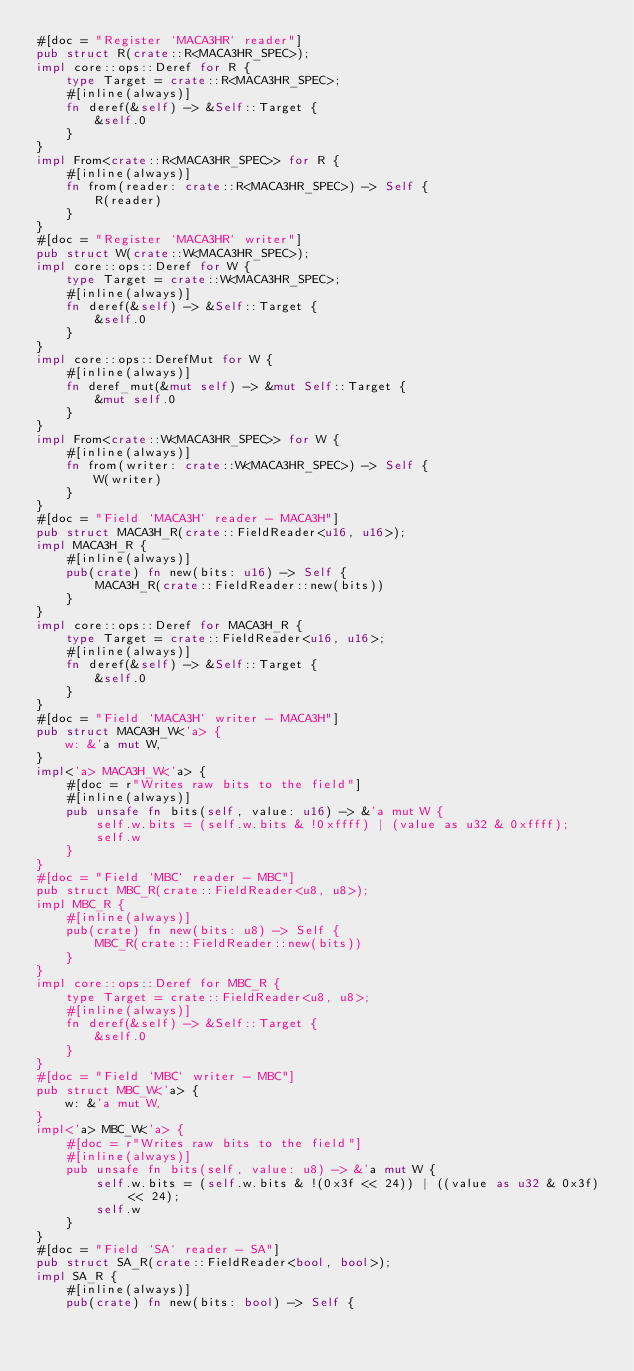Convert code to text. <code><loc_0><loc_0><loc_500><loc_500><_Rust_>#[doc = "Register `MACA3HR` reader"]
pub struct R(crate::R<MACA3HR_SPEC>);
impl core::ops::Deref for R {
    type Target = crate::R<MACA3HR_SPEC>;
    #[inline(always)]
    fn deref(&self) -> &Self::Target {
        &self.0
    }
}
impl From<crate::R<MACA3HR_SPEC>> for R {
    #[inline(always)]
    fn from(reader: crate::R<MACA3HR_SPEC>) -> Self {
        R(reader)
    }
}
#[doc = "Register `MACA3HR` writer"]
pub struct W(crate::W<MACA3HR_SPEC>);
impl core::ops::Deref for W {
    type Target = crate::W<MACA3HR_SPEC>;
    #[inline(always)]
    fn deref(&self) -> &Self::Target {
        &self.0
    }
}
impl core::ops::DerefMut for W {
    #[inline(always)]
    fn deref_mut(&mut self) -> &mut Self::Target {
        &mut self.0
    }
}
impl From<crate::W<MACA3HR_SPEC>> for W {
    #[inline(always)]
    fn from(writer: crate::W<MACA3HR_SPEC>) -> Self {
        W(writer)
    }
}
#[doc = "Field `MACA3H` reader - MACA3H"]
pub struct MACA3H_R(crate::FieldReader<u16, u16>);
impl MACA3H_R {
    #[inline(always)]
    pub(crate) fn new(bits: u16) -> Self {
        MACA3H_R(crate::FieldReader::new(bits))
    }
}
impl core::ops::Deref for MACA3H_R {
    type Target = crate::FieldReader<u16, u16>;
    #[inline(always)]
    fn deref(&self) -> &Self::Target {
        &self.0
    }
}
#[doc = "Field `MACA3H` writer - MACA3H"]
pub struct MACA3H_W<'a> {
    w: &'a mut W,
}
impl<'a> MACA3H_W<'a> {
    #[doc = r"Writes raw bits to the field"]
    #[inline(always)]
    pub unsafe fn bits(self, value: u16) -> &'a mut W {
        self.w.bits = (self.w.bits & !0xffff) | (value as u32 & 0xffff);
        self.w
    }
}
#[doc = "Field `MBC` reader - MBC"]
pub struct MBC_R(crate::FieldReader<u8, u8>);
impl MBC_R {
    #[inline(always)]
    pub(crate) fn new(bits: u8) -> Self {
        MBC_R(crate::FieldReader::new(bits))
    }
}
impl core::ops::Deref for MBC_R {
    type Target = crate::FieldReader<u8, u8>;
    #[inline(always)]
    fn deref(&self) -> &Self::Target {
        &self.0
    }
}
#[doc = "Field `MBC` writer - MBC"]
pub struct MBC_W<'a> {
    w: &'a mut W,
}
impl<'a> MBC_W<'a> {
    #[doc = r"Writes raw bits to the field"]
    #[inline(always)]
    pub unsafe fn bits(self, value: u8) -> &'a mut W {
        self.w.bits = (self.w.bits & !(0x3f << 24)) | ((value as u32 & 0x3f) << 24);
        self.w
    }
}
#[doc = "Field `SA` reader - SA"]
pub struct SA_R(crate::FieldReader<bool, bool>);
impl SA_R {
    #[inline(always)]
    pub(crate) fn new(bits: bool) -> Self {</code> 